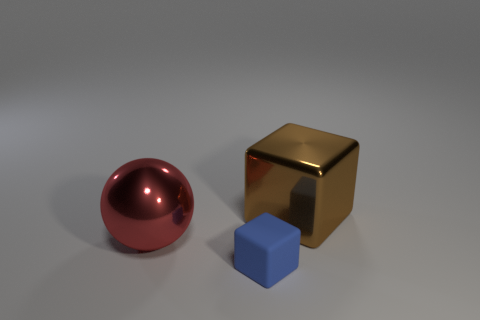Add 3 balls. How many objects exist? 6 Subtract all blocks. How many objects are left? 1 Add 3 rubber objects. How many rubber objects are left? 4 Add 3 purple rubber spheres. How many purple rubber spheres exist? 3 Subtract 0 yellow blocks. How many objects are left? 3 Subtract all metallic objects. Subtract all red things. How many objects are left? 0 